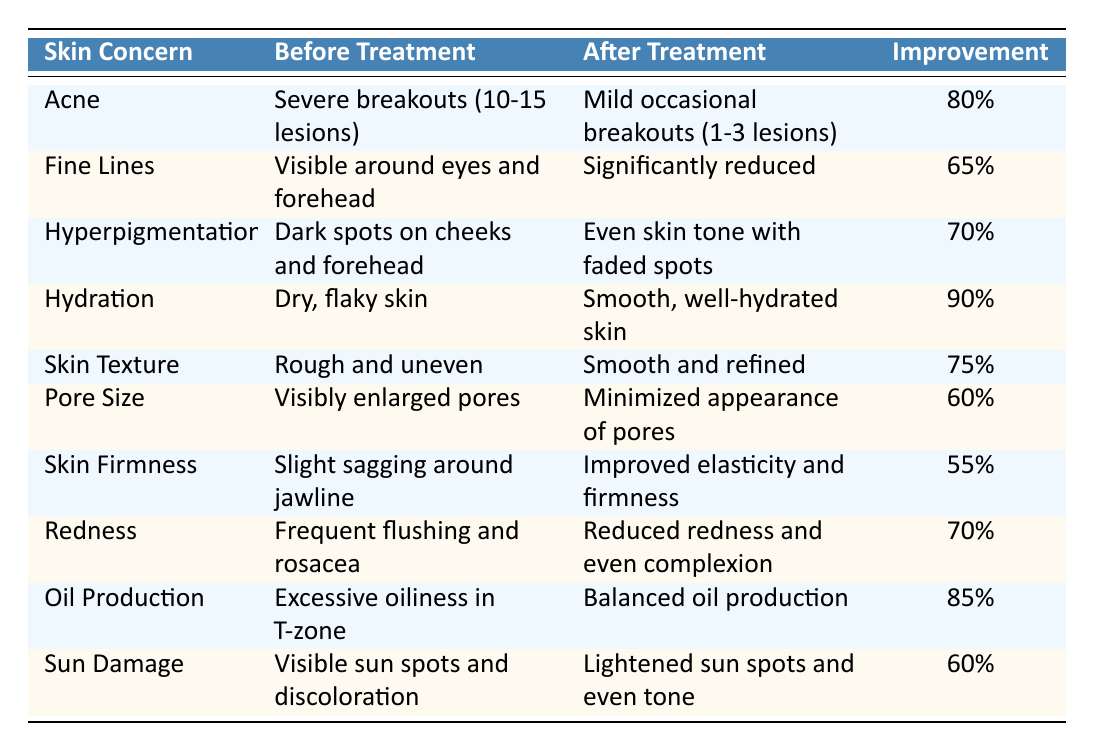What is the improvement percentage for hydration? The table shows that the improvement percentage for hydration is listed under the "Improvement Percentage" column next to hydration, which is 90%.
Answer: 90% Which skin concern showed the least improvement percentage? By looking at the "Improvement Percentage" column, the skin concern with the lowest value is skin firmness, which shows an improvement of 55%.
Answer: 55% How many skin concerns improved by over 80%? The table lists four skin concerns with improvement percentages above 80%: hydration (90%), oil production (85%), acne (80%). By counting these, there are three concerns.
Answer: 3 Is there an improvement for fine lines? The table indicates that fine lines improved from "Visible around eyes and forehead" to "Significantly reduced," so there is indeed an improvement.
Answer: Yes What was the improvement percentage for hyperpigmentation compared to that for redness? Hyperpigmentation improved by 70%, and redness also improved by 70%. Since both percentages are equal, we note that they are the same.
Answer: 70% Which skin concern had severe symptoms before treatment? The table indicates that acne had severe symptoms before treatment, specifically "Severe breakouts (10-15 lesions)."
Answer: Acne What is the average improvement percentage across all concerns? To find the average improvement percentage: (80 + 65 + 70 + 90 + 75 + 60 + 55 + 70 + 85 + 60) / 10 = 73.5%
Answer: 73.5% How did the appearance of pores change as a result of treatment? The table shows that the appearance of pores changed from "Visibly enlarged pores" to "Minimized appearance of pores," indicating a positive change.
Answer: Minimized appearance of pores What was the common improvement percentage for skin concerns related to hydration and oil production? The improvement percentage for hydration is 90%, and for oil production, it is 85%. Both were improvements related to skin texture and balance.
Answer: Hydration (90%), Oil Production (85%) Did sun damage have a significant improvement percentage? The improvement percentage for sun damage is 60%, which indicates a moderate improvement but not highly significant compared to others.
Answer: 60% 